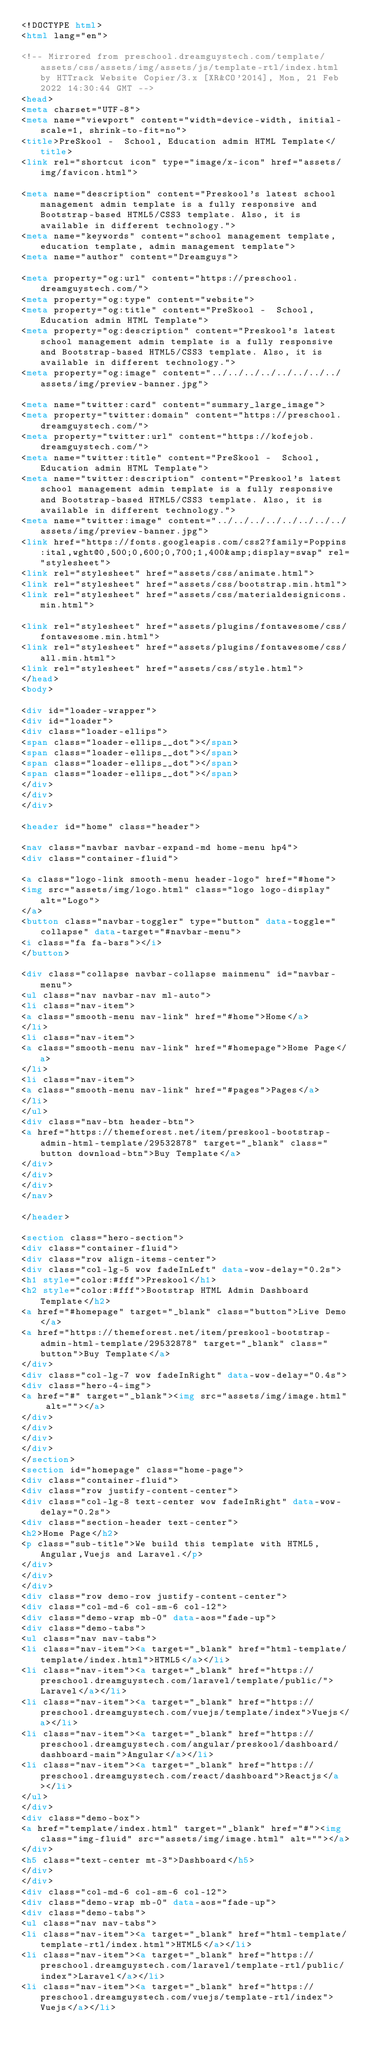Convert code to text. <code><loc_0><loc_0><loc_500><loc_500><_HTML_><!DOCTYPE html>
<html lang="en">

<!-- Mirrored from preschool.dreamguystech.com/template/assets/css/assets/img/assets/js/template-rtl/index.html by HTTrack Website Copier/3.x [XR&CO'2014], Mon, 21 Feb 2022 14:30:44 GMT -->
<head>
<meta charset="UTF-8">
<meta name="viewport" content="width=device-width, initial-scale=1, shrink-to-fit=no">
<title>PreSkool -  School, Education admin HTML Template</title>
<link rel="shortcut icon" type="image/x-icon" href="assets/img/favicon.html">

<meta name="description" content="Preskool's latest school management admin template is a fully responsive and Bootstrap-based HTML5/CSS3 template. Also, it is available in different technology.">
<meta name="keywords" content="school management template, education template, admin management template">
<meta name="author" content="Dreamguys">

<meta property="og:url" content="https://preschool.dreamguystech.com/">
<meta property="og:type" content="website">
<meta property="og:title" content="PreSkool -  School, Education admin HTML Template">
<meta property="og:description" content="Preskool's latest school management admin template is a fully responsive and Bootstrap-based HTML5/CSS3 template. Also, it is available in different technology.">
<meta property="og:image" content="../../../../../../../../assets/img/preview-banner.jpg">

<meta name="twitter:card" content="summary_large_image">
<meta property="twitter:domain" content="https://preschool.dreamguystech.com/">
<meta property="twitter:url" content="https://kofejob.dreamguystech.com/">
<meta name="twitter:title" content="PreSkool -  School, Education admin HTML Template">
<meta name="twitter:description" content="Preskool's latest school management admin template is a fully responsive and Bootstrap-based HTML5/CSS3 template. Also, it is available in different technology.">
<meta name="twitter:image" content="../../../../../../../../assets/img/preview-banner.jpg">
<link href="https://fonts.googleapis.com/css2?family=Poppins:ital,wght@0,500;0,600;0,700;1,400&amp;display=swap" rel="stylesheet">
<link rel="stylesheet" href="assets/css/animate.html">
<link rel="stylesheet" href="assets/css/bootstrap.min.html">
<link rel="stylesheet" href="assets/css/materialdesignicons.min.html">

<link rel="stylesheet" href="assets/plugins/fontawesome/css/fontawesome.min.html">
<link rel="stylesheet" href="assets/plugins/fontawesome/css/all.min.html">
<link rel="stylesheet" href="assets/css/style.html">
</head>
<body>

<div id="loader-wrapper">
<div id="loader">
<div class="loader-ellips">
<span class="loader-ellips__dot"></span>
<span class="loader-ellips__dot"></span>
<span class="loader-ellips__dot"></span>
<span class="loader-ellips__dot"></span>
</div>
</div>
</div>

<header id="home" class="header">

<nav class="navbar navbar-expand-md home-menu hp4">
<div class="container-fluid">

<a class="logo-link smooth-menu header-logo" href="#home">
<img src="assets/img/logo.html" class="logo logo-display" alt="Logo">
</a>
<button class="navbar-toggler" type="button" data-toggle="collapse" data-target="#navbar-menu">
<i class="fa fa-bars"></i>
</button>

<div class="collapse navbar-collapse mainmenu" id="navbar-menu">
<ul class="nav navbar-nav ml-auto">
<li class="nav-item">
<a class="smooth-menu nav-link" href="#home">Home</a>
</li>
<li class="nav-item">
<a class="smooth-menu nav-link" href="#homepage">Home Page</a>
</li>
<li class="nav-item">
<a class="smooth-menu nav-link" href="#pages">Pages</a>
</li>
</ul>
<div class="nav-btn header-btn">
<a href="https://themeforest.net/item/preskool-bootstrap-admin-html-template/29532878" target="_blank" class="button download-btn">Buy Template</a>
</div>
</div>
</div>
</nav>

</header>

<section class="hero-section">
<div class="container-fluid">
<div class="row align-items-center">
<div class="col-lg-5 wow fadeInLeft" data-wow-delay="0.2s">
<h1 style="color:#fff">Preskool</h1>
<h2 style="color:#fff">Bootstrap HTML Admin Dashboard Template</h2>
<a href="#homepage" target="_blank" class="button">Live Demo</a>
<a href="https://themeforest.net/item/preskool-bootstrap-admin-html-template/29532878" target="_blank" class="button">Buy Template</a>
</div>
<div class="col-lg-7 wow fadeInRight" data-wow-delay="0.4s">
<div class="hero-4-img">
<a href="#" target="_blank"><img src="assets/img/image.html" alt=""></a>
</div>
</div>
</div>
</div>
</section>
<section id="homepage" class="home-page">
<div class="container-fluid">
<div class="row justify-content-center">
<div class="col-lg-8 text-center wow fadeInRight" data-wow-delay="0.2s">
<div class="section-header text-center">
<h2>Home Page</h2>
<p class="sub-title">We build this template with HTML5,Angular,Vuejs and Laravel.</p>
</div>
</div>
</div>
<div class="row demo-row justify-content-center">
<div class="col-md-6 col-sm-6 col-12">
<div class="demo-wrap mb-0" data-aos="fade-up">
<div class="demo-tabs">
<ul class="nav nav-tabs">
<li class="nav-item"><a target="_blank" href="html-template/template/index.html">HTML5</a></li>
<li class="nav-item"><a target="_blank" href="https://preschool.dreamguystech.com/laravel/template/public/">Laravel</a></li>
<li class="nav-item"><a target="_blank" href="https://preschool.dreamguystech.com/vuejs/template/index">Vuejs</a></li>
<li class="nav-item"><a target="_blank" href="https://preschool.dreamguystech.com/angular/preskool/dashboard/dashboard-main">Angular</a></li>
<li class="nav-item"><a target="_blank" href="https://preschool.dreamguystech.com/react/dashboard">Reactjs</a></li>
</ul>
</div>
<div class="demo-box">
<a href="template/index.html" target="_blank" href="#"><img class="img-fluid" src="assets/img/image.html" alt=""></a>
</div>
<h5 class="text-center mt-3">Dashboard</h5>
</div>
</div>
<div class="col-md-6 col-sm-6 col-12">
<div class="demo-wrap mb-0" data-aos="fade-up">
<div class="demo-tabs">
<ul class="nav nav-tabs">
<li class="nav-item"><a target="_blank" href="html-template/template-rtl/index.html">HTML5</a></li>
<li class="nav-item"><a target="_blank" href="https://preschool.dreamguystech.com/laravel/template-rtl/public/index">Laravel</a></li>
<li class="nav-item"><a target="_blank" href="https://preschool.dreamguystech.com/vuejs/template-rtl/index">Vuejs</a></li></code> 